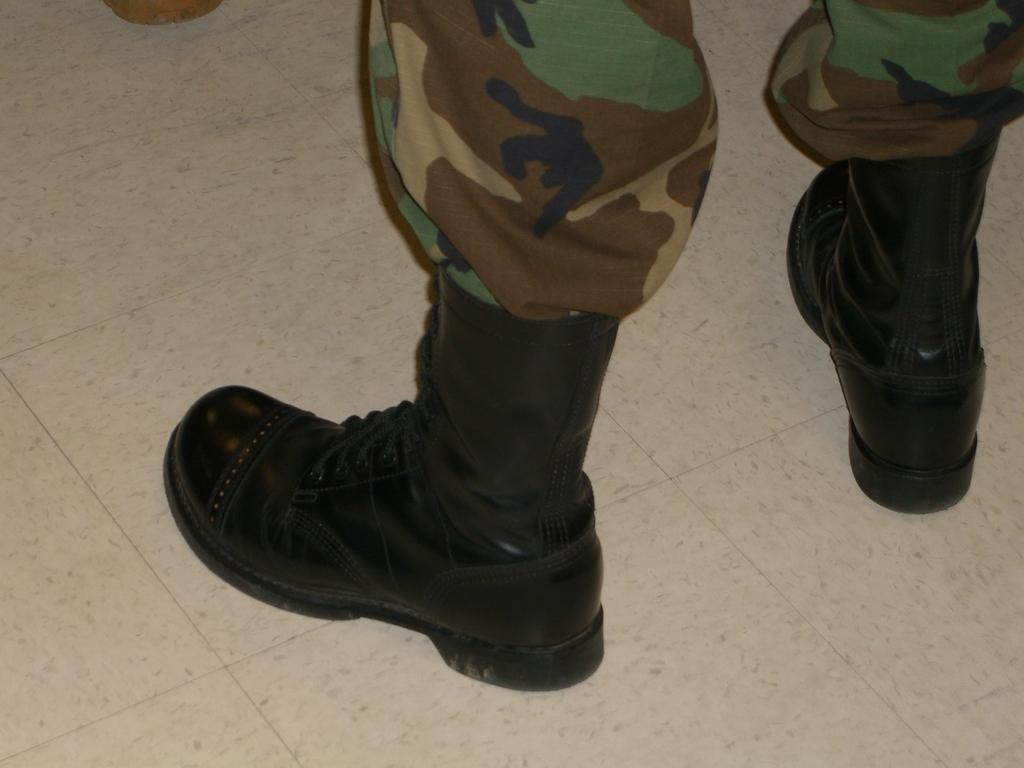What part of a person or object can be seen in the image? There are legs visible in the image. Where are the legs located? The legs are on the floor. How many rabbits can be seen hopping around the oven in the image? There are no rabbits or ovens present in the image; it only shows legs on the floor. 